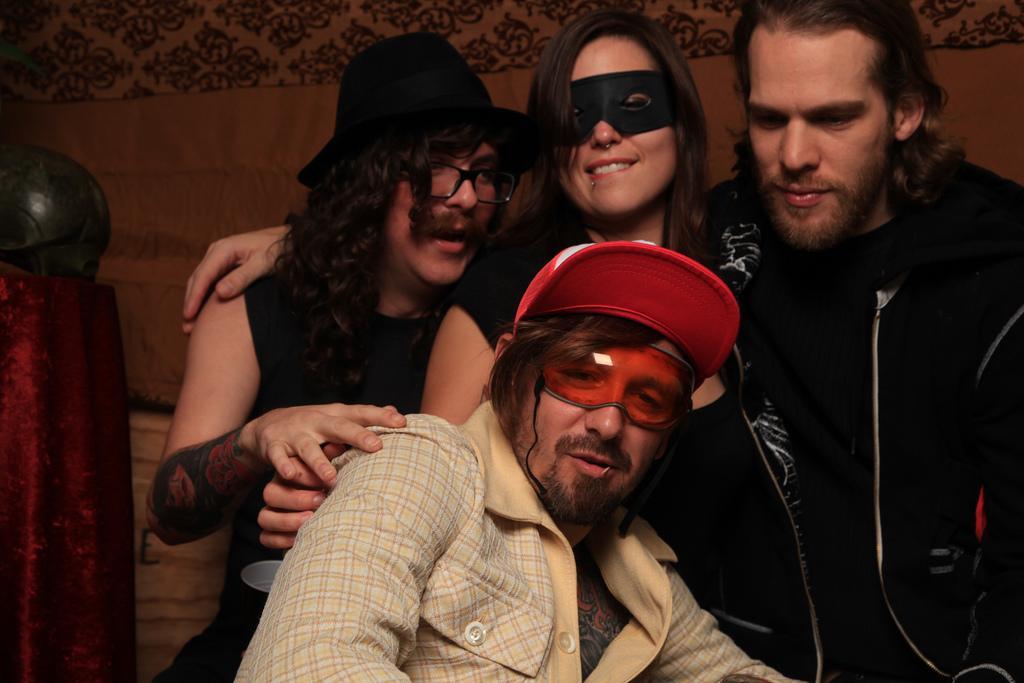Can you describe this image briefly? In this image, we can see four people are smiling. Background we can see a wall. Left side of the image, we can see red and black color objects. Here we can see a tattoo on the human hand. 